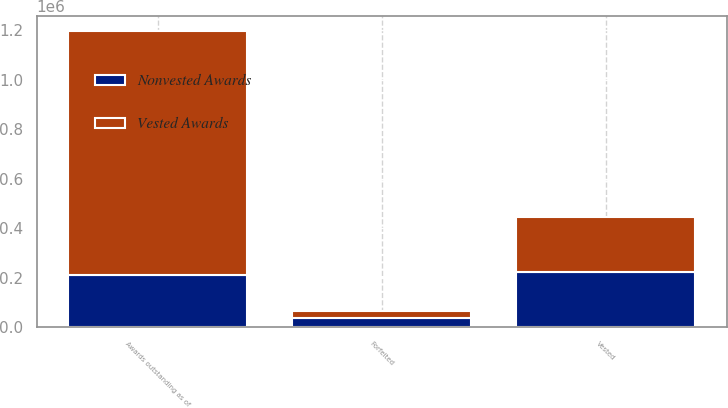Convert chart to OTSL. <chart><loc_0><loc_0><loc_500><loc_500><stacked_bar_chart><ecel><fcel>Awards outstanding as of<fcel>Vested<fcel>Forfeited<nl><fcel>Vested Awards<fcel>989414<fcel>222250<fcel>26667<nl><fcel>Nonvested Awards<fcel>208916<fcel>222250<fcel>37969<nl></chart> 